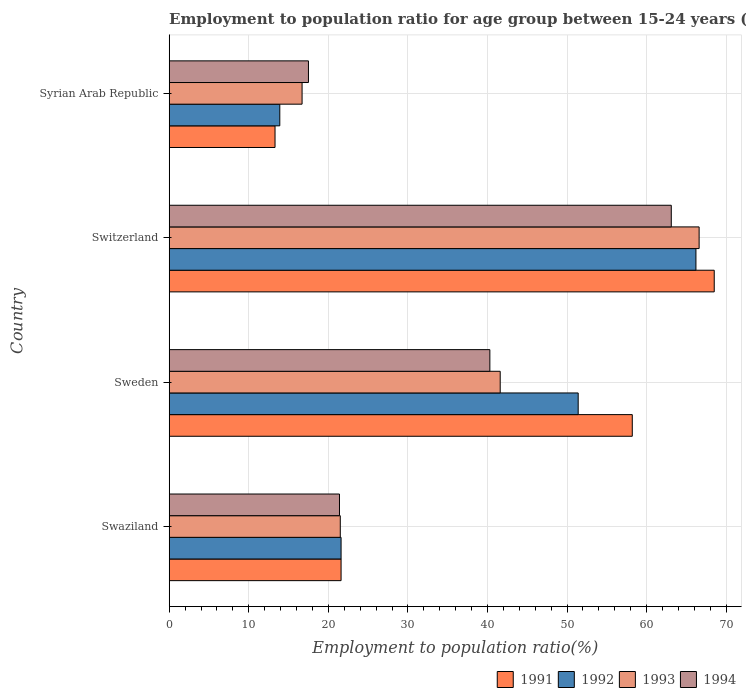How many different coloured bars are there?
Make the answer very short. 4. How many groups of bars are there?
Keep it short and to the point. 4. Are the number of bars per tick equal to the number of legend labels?
Keep it short and to the point. Yes. Are the number of bars on each tick of the Y-axis equal?
Keep it short and to the point. Yes. How many bars are there on the 3rd tick from the bottom?
Your response must be concise. 4. What is the label of the 2nd group of bars from the top?
Your answer should be very brief. Switzerland. In how many cases, is the number of bars for a given country not equal to the number of legend labels?
Your response must be concise. 0. What is the employment to population ratio in 1994 in Switzerland?
Ensure brevity in your answer.  63.1. Across all countries, what is the maximum employment to population ratio in 1993?
Offer a terse response. 66.6. Across all countries, what is the minimum employment to population ratio in 1992?
Offer a terse response. 13.9. In which country was the employment to population ratio in 1994 maximum?
Offer a very short reply. Switzerland. In which country was the employment to population ratio in 1993 minimum?
Provide a succinct answer. Syrian Arab Republic. What is the total employment to population ratio in 1994 in the graph?
Ensure brevity in your answer.  142.3. What is the difference between the employment to population ratio in 1993 in Swaziland and that in Switzerland?
Provide a short and direct response. -45.1. What is the difference between the employment to population ratio in 1992 in Switzerland and the employment to population ratio in 1994 in Swaziland?
Keep it short and to the point. 44.8. What is the average employment to population ratio in 1993 per country?
Keep it short and to the point. 36.6. What is the difference between the employment to population ratio in 1992 and employment to population ratio in 1994 in Swaziland?
Provide a short and direct response. 0.2. In how many countries, is the employment to population ratio in 1992 greater than 8 %?
Provide a succinct answer. 4. What is the ratio of the employment to population ratio in 1994 in Swaziland to that in Syrian Arab Republic?
Ensure brevity in your answer.  1.22. Is the employment to population ratio in 1992 in Sweden less than that in Syrian Arab Republic?
Give a very brief answer. No. What is the difference between the highest and the second highest employment to population ratio in 1993?
Your response must be concise. 25. What is the difference between the highest and the lowest employment to population ratio in 1991?
Make the answer very short. 55.2. Is the sum of the employment to population ratio in 1991 in Swaziland and Sweden greater than the maximum employment to population ratio in 1992 across all countries?
Make the answer very short. Yes. What does the 1st bar from the top in Syrian Arab Republic represents?
Offer a very short reply. 1994. What does the 3rd bar from the bottom in Swaziland represents?
Your response must be concise. 1993. Is it the case that in every country, the sum of the employment to population ratio in 1993 and employment to population ratio in 1994 is greater than the employment to population ratio in 1991?
Your answer should be compact. Yes. What is the difference between two consecutive major ticks on the X-axis?
Offer a terse response. 10. Does the graph contain grids?
Your answer should be compact. Yes. Where does the legend appear in the graph?
Your response must be concise. Bottom right. How many legend labels are there?
Your answer should be compact. 4. What is the title of the graph?
Offer a very short reply. Employment to population ratio for age group between 15-24 years (females). Does "1991" appear as one of the legend labels in the graph?
Your answer should be compact. Yes. What is the label or title of the X-axis?
Your response must be concise. Employment to population ratio(%). What is the label or title of the Y-axis?
Keep it short and to the point. Country. What is the Employment to population ratio(%) in 1991 in Swaziland?
Give a very brief answer. 21.6. What is the Employment to population ratio(%) of 1992 in Swaziland?
Your response must be concise. 21.6. What is the Employment to population ratio(%) of 1993 in Swaziland?
Ensure brevity in your answer.  21.5. What is the Employment to population ratio(%) of 1994 in Swaziland?
Make the answer very short. 21.4. What is the Employment to population ratio(%) of 1991 in Sweden?
Keep it short and to the point. 58.2. What is the Employment to population ratio(%) in 1992 in Sweden?
Provide a short and direct response. 51.4. What is the Employment to population ratio(%) in 1993 in Sweden?
Provide a succinct answer. 41.6. What is the Employment to population ratio(%) of 1994 in Sweden?
Ensure brevity in your answer.  40.3. What is the Employment to population ratio(%) of 1991 in Switzerland?
Your response must be concise. 68.5. What is the Employment to population ratio(%) of 1992 in Switzerland?
Give a very brief answer. 66.2. What is the Employment to population ratio(%) of 1993 in Switzerland?
Your response must be concise. 66.6. What is the Employment to population ratio(%) in 1994 in Switzerland?
Ensure brevity in your answer.  63.1. What is the Employment to population ratio(%) in 1991 in Syrian Arab Republic?
Offer a very short reply. 13.3. What is the Employment to population ratio(%) of 1992 in Syrian Arab Republic?
Keep it short and to the point. 13.9. What is the Employment to population ratio(%) in 1993 in Syrian Arab Republic?
Provide a short and direct response. 16.7. Across all countries, what is the maximum Employment to population ratio(%) of 1991?
Offer a terse response. 68.5. Across all countries, what is the maximum Employment to population ratio(%) in 1992?
Ensure brevity in your answer.  66.2. Across all countries, what is the maximum Employment to population ratio(%) in 1993?
Offer a very short reply. 66.6. Across all countries, what is the maximum Employment to population ratio(%) of 1994?
Offer a very short reply. 63.1. Across all countries, what is the minimum Employment to population ratio(%) in 1991?
Your answer should be compact. 13.3. Across all countries, what is the minimum Employment to population ratio(%) of 1992?
Give a very brief answer. 13.9. Across all countries, what is the minimum Employment to population ratio(%) in 1993?
Offer a very short reply. 16.7. What is the total Employment to population ratio(%) in 1991 in the graph?
Your response must be concise. 161.6. What is the total Employment to population ratio(%) of 1992 in the graph?
Provide a succinct answer. 153.1. What is the total Employment to population ratio(%) of 1993 in the graph?
Provide a short and direct response. 146.4. What is the total Employment to population ratio(%) in 1994 in the graph?
Ensure brevity in your answer.  142.3. What is the difference between the Employment to population ratio(%) in 1991 in Swaziland and that in Sweden?
Your answer should be very brief. -36.6. What is the difference between the Employment to population ratio(%) of 1992 in Swaziland and that in Sweden?
Provide a short and direct response. -29.8. What is the difference between the Employment to population ratio(%) of 1993 in Swaziland and that in Sweden?
Offer a very short reply. -20.1. What is the difference between the Employment to population ratio(%) of 1994 in Swaziland and that in Sweden?
Offer a very short reply. -18.9. What is the difference between the Employment to population ratio(%) in 1991 in Swaziland and that in Switzerland?
Provide a short and direct response. -46.9. What is the difference between the Employment to population ratio(%) of 1992 in Swaziland and that in Switzerland?
Offer a very short reply. -44.6. What is the difference between the Employment to population ratio(%) of 1993 in Swaziland and that in Switzerland?
Your answer should be very brief. -45.1. What is the difference between the Employment to population ratio(%) in 1994 in Swaziland and that in Switzerland?
Your answer should be very brief. -41.7. What is the difference between the Employment to population ratio(%) of 1992 in Swaziland and that in Syrian Arab Republic?
Provide a succinct answer. 7.7. What is the difference between the Employment to population ratio(%) of 1993 in Swaziland and that in Syrian Arab Republic?
Your answer should be very brief. 4.8. What is the difference between the Employment to population ratio(%) of 1994 in Swaziland and that in Syrian Arab Republic?
Ensure brevity in your answer.  3.9. What is the difference between the Employment to population ratio(%) in 1992 in Sweden and that in Switzerland?
Keep it short and to the point. -14.8. What is the difference between the Employment to population ratio(%) in 1994 in Sweden and that in Switzerland?
Your response must be concise. -22.8. What is the difference between the Employment to population ratio(%) in 1991 in Sweden and that in Syrian Arab Republic?
Keep it short and to the point. 44.9. What is the difference between the Employment to population ratio(%) of 1992 in Sweden and that in Syrian Arab Republic?
Ensure brevity in your answer.  37.5. What is the difference between the Employment to population ratio(%) in 1993 in Sweden and that in Syrian Arab Republic?
Provide a short and direct response. 24.9. What is the difference between the Employment to population ratio(%) in 1994 in Sweden and that in Syrian Arab Republic?
Your answer should be compact. 22.8. What is the difference between the Employment to population ratio(%) in 1991 in Switzerland and that in Syrian Arab Republic?
Provide a short and direct response. 55.2. What is the difference between the Employment to population ratio(%) in 1992 in Switzerland and that in Syrian Arab Republic?
Your answer should be very brief. 52.3. What is the difference between the Employment to population ratio(%) in 1993 in Switzerland and that in Syrian Arab Republic?
Give a very brief answer. 49.9. What is the difference between the Employment to population ratio(%) of 1994 in Switzerland and that in Syrian Arab Republic?
Your response must be concise. 45.6. What is the difference between the Employment to population ratio(%) of 1991 in Swaziland and the Employment to population ratio(%) of 1992 in Sweden?
Offer a very short reply. -29.8. What is the difference between the Employment to population ratio(%) of 1991 in Swaziland and the Employment to population ratio(%) of 1994 in Sweden?
Your answer should be compact. -18.7. What is the difference between the Employment to population ratio(%) of 1992 in Swaziland and the Employment to population ratio(%) of 1993 in Sweden?
Offer a terse response. -20. What is the difference between the Employment to population ratio(%) in 1992 in Swaziland and the Employment to population ratio(%) in 1994 in Sweden?
Your response must be concise. -18.7. What is the difference between the Employment to population ratio(%) of 1993 in Swaziland and the Employment to population ratio(%) of 1994 in Sweden?
Provide a succinct answer. -18.8. What is the difference between the Employment to population ratio(%) in 1991 in Swaziland and the Employment to population ratio(%) in 1992 in Switzerland?
Your response must be concise. -44.6. What is the difference between the Employment to population ratio(%) in 1991 in Swaziland and the Employment to population ratio(%) in 1993 in Switzerland?
Keep it short and to the point. -45. What is the difference between the Employment to population ratio(%) in 1991 in Swaziland and the Employment to population ratio(%) in 1994 in Switzerland?
Make the answer very short. -41.5. What is the difference between the Employment to population ratio(%) of 1992 in Swaziland and the Employment to population ratio(%) of 1993 in Switzerland?
Offer a terse response. -45. What is the difference between the Employment to population ratio(%) in 1992 in Swaziland and the Employment to population ratio(%) in 1994 in Switzerland?
Provide a succinct answer. -41.5. What is the difference between the Employment to population ratio(%) of 1993 in Swaziland and the Employment to population ratio(%) of 1994 in Switzerland?
Ensure brevity in your answer.  -41.6. What is the difference between the Employment to population ratio(%) of 1991 in Swaziland and the Employment to population ratio(%) of 1992 in Syrian Arab Republic?
Your answer should be compact. 7.7. What is the difference between the Employment to population ratio(%) of 1991 in Swaziland and the Employment to population ratio(%) of 1993 in Syrian Arab Republic?
Ensure brevity in your answer.  4.9. What is the difference between the Employment to population ratio(%) of 1992 in Swaziland and the Employment to population ratio(%) of 1993 in Syrian Arab Republic?
Provide a short and direct response. 4.9. What is the difference between the Employment to population ratio(%) in 1992 in Swaziland and the Employment to population ratio(%) in 1994 in Syrian Arab Republic?
Provide a succinct answer. 4.1. What is the difference between the Employment to population ratio(%) of 1993 in Swaziland and the Employment to population ratio(%) of 1994 in Syrian Arab Republic?
Provide a succinct answer. 4. What is the difference between the Employment to population ratio(%) of 1991 in Sweden and the Employment to population ratio(%) of 1992 in Switzerland?
Offer a very short reply. -8. What is the difference between the Employment to population ratio(%) of 1992 in Sweden and the Employment to population ratio(%) of 1993 in Switzerland?
Provide a succinct answer. -15.2. What is the difference between the Employment to population ratio(%) in 1993 in Sweden and the Employment to population ratio(%) in 1994 in Switzerland?
Give a very brief answer. -21.5. What is the difference between the Employment to population ratio(%) of 1991 in Sweden and the Employment to population ratio(%) of 1992 in Syrian Arab Republic?
Ensure brevity in your answer.  44.3. What is the difference between the Employment to population ratio(%) in 1991 in Sweden and the Employment to population ratio(%) in 1993 in Syrian Arab Republic?
Your answer should be compact. 41.5. What is the difference between the Employment to population ratio(%) in 1991 in Sweden and the Employment to population ratio(%) in 1994 in Syrian Arab Republic?
Your answer should be very brief. 40.7. What is the difference between the Employment to population ratio(%) of 1992 in Sweden and the Employment to population ratio(%) of 1993 in Syrian Arab Republic?
Make the answer very short. 34.7. What is the difference between the Employment to population ratio(%) in 1992 in Sweden and the Employment to population ratio(%) in 1994 in Syrian Arab Republic?
Your answer should be compact. 33.9. What is the difference between the Employment to population ratio(%) of 1993 in Sweden and the Employment to population ratio(%) of 1994 in Syrian Arab Republic?
Your response must be concise. 24.1. What is the difference between the Employment to population ratio(%) of 1991 in Switzerland and the Employment to population ratio(%) of 1992 in Syrian Arab Republic?
Ensure brevity in your answer.  54.6. What is the difference between the Employment to population ratio(%) in 1991 in Switzerland and the Employment to population ratio(%) in 1993 in Syrian Arab Republic?
Ensure brevity in your answer.  51.8. What is the difference between the Employment to population ratio(%) in 1992 in Switzerland and the Employment to population ratio(%) in 1993 in Syrian Arab Republic?
Give a very brief answer. 49.5. What is the difference between the Employment to population ratio(%) of 1992 in Switzerland and the Employment to population ratio(%) of 1994 in Syrian Arab Republic?
Keep it short and to the point. 48.7. What is the difference between the Employment to population ratio(%) in 1993 in Switzerland and the Employment to population ratio(%) in 1994 in Syrian Arab Republic?
Keep it short and to the point. 49.1. What is the average Employment to population ratio(%) in 1991 per country?
Offer a terse response. 40.4. What is the average Employment to population ratio(%) of 1992 per country?
Your answer should be very brief. 38.27. What is the average Employment to population ratio(%) of 1993 per country?
Your answer should be compact. 36.6. What is the average Employment to population ratio(%) of 1994 per country?
Your response must be concise. 35.58. What is the difference between the Employment to population ratio(%) of 1991 and Employment to population ratio(%) of 1994 in Swaziland?
Offer a terse response. 0.2. What is the difference between the Employment to population ratio(%) of 1992 and Employment to population ratio(%) of 1993 in Swaziland?
Your answer should be compact. 0.1. What is the difference between the Employment to population ratio(%) of 1992 and Employment to population ratio(%) of 1994 in Swaziland?
Ensure brevity in your answer.  0.2. What is the difference between the Employment to population ratio(%) of 1993 and Employment to population ratio(%) of 1994 in Swaziland?
Ensure brevity in your answer.  0.1. What is the difference between the Employment to population ratio(%) in 1991 and Employment to population ratio(%) in 1992 in Sweden?
Offer a very short reply. 6.8. What is the difference between the Employment to population ratio(%) in 1992 and Employment to population ratio(%) in 1993 in Sweden?
Your answer should be compact. 9.8. What is the difference between the Employment to population ratio(%) of 1993 and Employment to population ratio(%) of 1994 in Sweden?
Your answer should be compact. 1.3. What is the difference between the Employment to population ratio(%) of 1991 and Employment to population ratio(%) of 1992 in Switzerland?
Provide a short and direct response. 2.3. What is the difference between the Employment to population ratio(%) of 1991 and Employment to population ratio(%) of 1993 in Switzerland?
Make the answer very short. 1.9. What is the difference between the Employment to population ratio(%) in 1991 and Employment to population ratio(%) in 1994 in Switzerland?
Offer a terse response. 5.4. What is the difference between the Employment to population ratio(%) in 1992 and Employment to population ratio(%) in 1993 in Switzerland?
Offer a terse response. -0.4. What is the difference between the Employment to population ratio(%) in 1992 and Employment to population ratio(%) in 1994 in Switzerland?
Offer a terse response. 3.1. What is the difference between the Employment to population ratio(%) of 1993 and Employment to population ratio(%) of 1994 in Switzerland?
Make the answer very short. 3.5. What is the difference between the Employment to population ratio(%) in 1991 and Employment to population ratio(%) in 1992 in Syrian Arab Republic?
Offer a terse response. -0.6. What is the difference between the Employment to population ratio(%) of 1991 and Employment to population ratio(%) of 1993 in Syrian Arab Republic?
Give a very brief answer. -3.4. What is the difference between the Employment to population ratio(%) in 1991 and Employment to population ratio(%) in 1994 in Syrian Arab Republic?
Make the answer very short. -4.2. What is the difference between the Employment to population ratio(%) in 1992 and Employment to population ratio(%) in 1993 in Syrian Arab Republic?
Your response must be concise. -2.8. What is the ratio of the Employment to population ratio(%) of 1991 in Swaziland to that in Sweden?
Your answer should be compact. 0.37. What is the ratio of the Employment to population ratio(%) of 1992 in Swaziland to that in Sweden?
Keep it short and to the point. 0.42. What is the ratio of the Employment to population ratio(%) of 1993 in Swaziland to that in Sweden?
Your response must be concise. 0.52. What is the ratio of the Employment to population ratio(%) of 1994 in Swaziland to that in Sweden?
Your answer should be very brief. 0.53. What is the ratio of the Employment to population ratio(%) in 1991 in Swaziland to that in Switzerland?
Your response must be concise. 0.32. What is the ratio of the Employment to population ratio(%) in 1992 in Swaziland to that in Switzerland?
Make the answer very short. 0.33. What is the ratio of the Employment to population ratio(%) of 1993 in Swaziland to that in Switzerland?
Offer a terse response. 0.32. What is the ratio of the Employment to population ratio(%) in 1994 in Swaziland to that in Switzerland?
Give a very brief answer. 0.34. What is the ratio of the Employment to population ratio(%) in 1991 in Swaziland to that in Syrian Arab Republic?
Give a very brief answer. 1.62. What is the ratio of the Employment to population ratio(%) of 1992 in Swaziland to that in Syrian Arab Republic?
Your answer should be very brief. 1.55. What is the ratio of the Employment to population ratio(%) of 1993 in Swaziland to that in Syrian Arab Republic?
Your response must be concise. 1.29. What is the ratio of the Employment to population ratio(%) in 1994 in Swaziland to that in Syrian Arab Republic?
Keep it short and to the point. 1.22. What is the ratio of the Employment to population ratio(%) of 1991 in Sweden to that in Switzerland?
Make the answer very short. 0.85. What is the ratio of the Employment to population ratio(%) of 1992 in Sweden to that in Switzerland?
Make the answer very short. 0.78. What is the ratio of the Employment to population ratio(%) of 1993 in Sweden to that in Switzerland?
Give a very brief answer. 0.62. What is the ratio of the Employment to population ratio(%) of 1994 in Sweden to that in Switzerland?
Offer a very short reply. 0.64. What is the ratio of the Employment to population ratio(%) of 1991 in Sweden to that in Syrian Arab Republic?
Your response must be concise. 4.38. What is the ratio of the Employment to population ratio(%) of 1992 in Sweden to that in Syrian Arab Republic?
Provide a short and direct response. 3.7. What is the ratio of the Employment to population ratio(%) in 1993 in Sweden to that in Syrian Arab Republic?
Give a very brief answer. 2.49. What is the ratio of the Employment to population ratio(%) of 1994 in Sweden to that in Syrian Arab Republic?
Offer a very short reply. 2.3. What is the ratio of the Employment to population ratio(%) in 1991 in Switzerland to that in Syrian Arab Republic?
Your response must be concise. 5.15. What is the ratio of the Employment to population ratio(%) of 1992 in Switzerland to that in Syrian Arab Republic?
Your answer should be very brief. 4.76. What is the ratio of the Employment to population ratio(%) of 1993 in Switzerland to that in Syrian Arab Republic?
Ensure brevity in your answer.  3.99. What is the ratio of the Employment to population ratio(%) in 1994 in Switzerland to that in Syrian Arab Republic?
Your answer should be very brief. 3.61. What is the difference between the highest and the second highest Employment to population ratio(%) of 1992?
Offer a very short reply. 14.8. What is the difference between the highest and the second highest Employment to population ratio(%) in 1993?
Your answer should be compact. 25. What is the difference between the highest and the second highest Employment to population ratio(%) of 1994?
Keep it short and to the point. 22.8. What is the difference between the highest and the lowest Employment to population ratio(%) of 1991?
Provide a succinct answer. 55.2. What is the difference between the highest and the lowest Employment to population ratio(%) of 1992?
Provide a succinct answer. 52.3. What is the difference between the highest and the lowest Employment to population ratio(%) of 1993?
Provide a succinct answer. 49.9. What is the difference between the highest and the lowest Employment to population ratio(%) in 1994?
Provide a succinct answer. 45.6. 